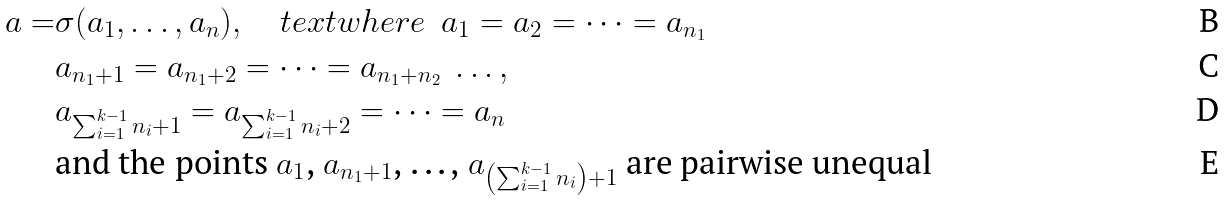<formula> <loc_0><loc_0><loc_500><loc_500>a = & \sigma ( a _ { 1 } , \dots , a _ { n } ) , \quad t e x t { w h e r e } \ \ a _ { 1 } = a _ { 2 } = \dots = a _ { n _ { 1 } } \\ & a _ { n _ { 1 } + 1 } = a _ { n _ { 1 } + 2 } = \dots = a _ { n _ { 1 } + n _ { 2 } } \ \dots , \\ & a _ { \sum _ { i = 1 } ^ { k - 1 } n _ { i } + 1 } = a _ { \sum _ { i = 1 } ^ { k - 1 } n _ { i } + 2 } = \dots = a _ { n } \\ & \text {and the points $a_{1}$, $a_{n_{1}+1}$, \dots, $a_{\left(\sum_{i=1}^{k-1} n_{i}\right)+1}$ are pairwise unequal}</formula> 